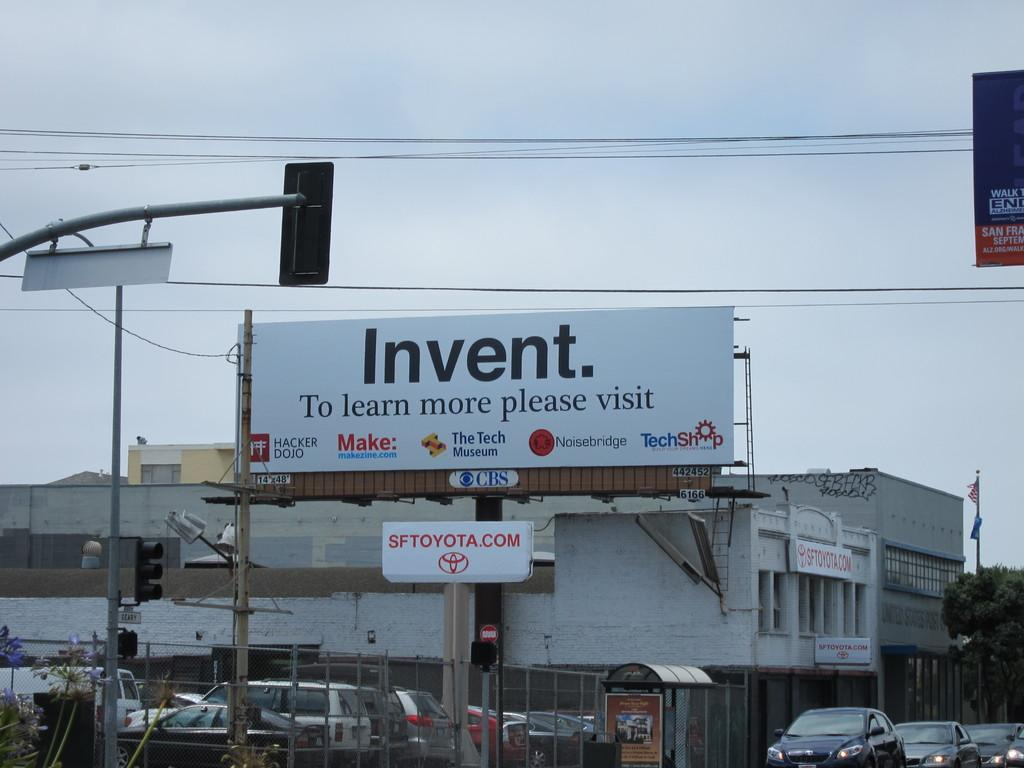Provide a one-sentence caption for the provided image. A white billboard with text "Invent. To learn more please visit HACKER DOJO, Make: makenzie.com, The Tech Museum, Noisebridge, TechShop Build Your Dreams Here" in front of two white buildings. 